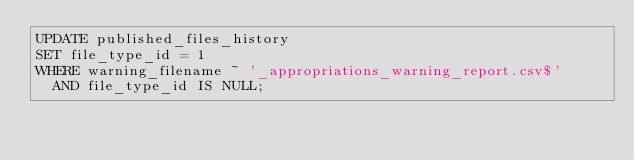<code> <loc_0><loc_0><loc_500><loc_500><_SQL_>UPDATE published_files_history
SET file_type_id = 1
WHERE warning_filename ~ '_appropriations_warning_report.csv$'
  AND file_type_id IS NULL;
</code> 